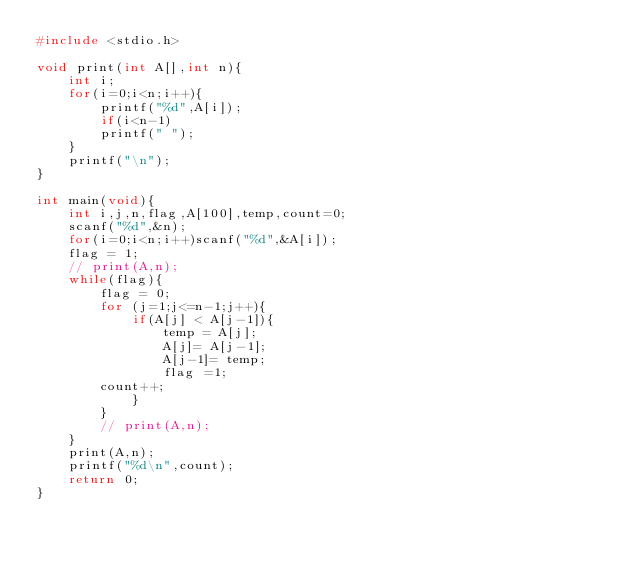<code> <loc_0><loc_0><loc_500><loc_500><_C_>#include <stdio.h>

void print(int A[],int n){
	int i;
	for(i=0;i<n;i++){
		printf("%d",A[i]);
		if(i<n-1)
		printf(" ");
	}
	printf("\n");
}

int main(void){
	int i,j,n,flag,A[100],temp,count=0;
	scanf("%d",&n);
	for(i=0;i<n;i++)scanf("%d",&A[i]);
	flag = 1;
	// print(A,n);
	while(flag){
		flag = 0;
		for (j=1;j<=n-1;j++){
			if(A[j] < A[j-1]){
				temp = A[j];
				A[j]= A[j-1];
				A[j-1]= temp;
				flag =1;
		count++;
			}
		}
		// print(A,n);
	}
	print(A,n);
	printf("%d\n",count);
	return 0;
}</code> 